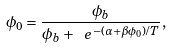Convert formula to latex. <formula><loc_0><loc_0><loc_500><loc_500>\phi _ { 0 } = \frac { \phi _ { b } } { \phi _ { b } + \ e ^ { - ( \alpha + \beta \phi _ { 0 } ) / T } } ,</formula> 